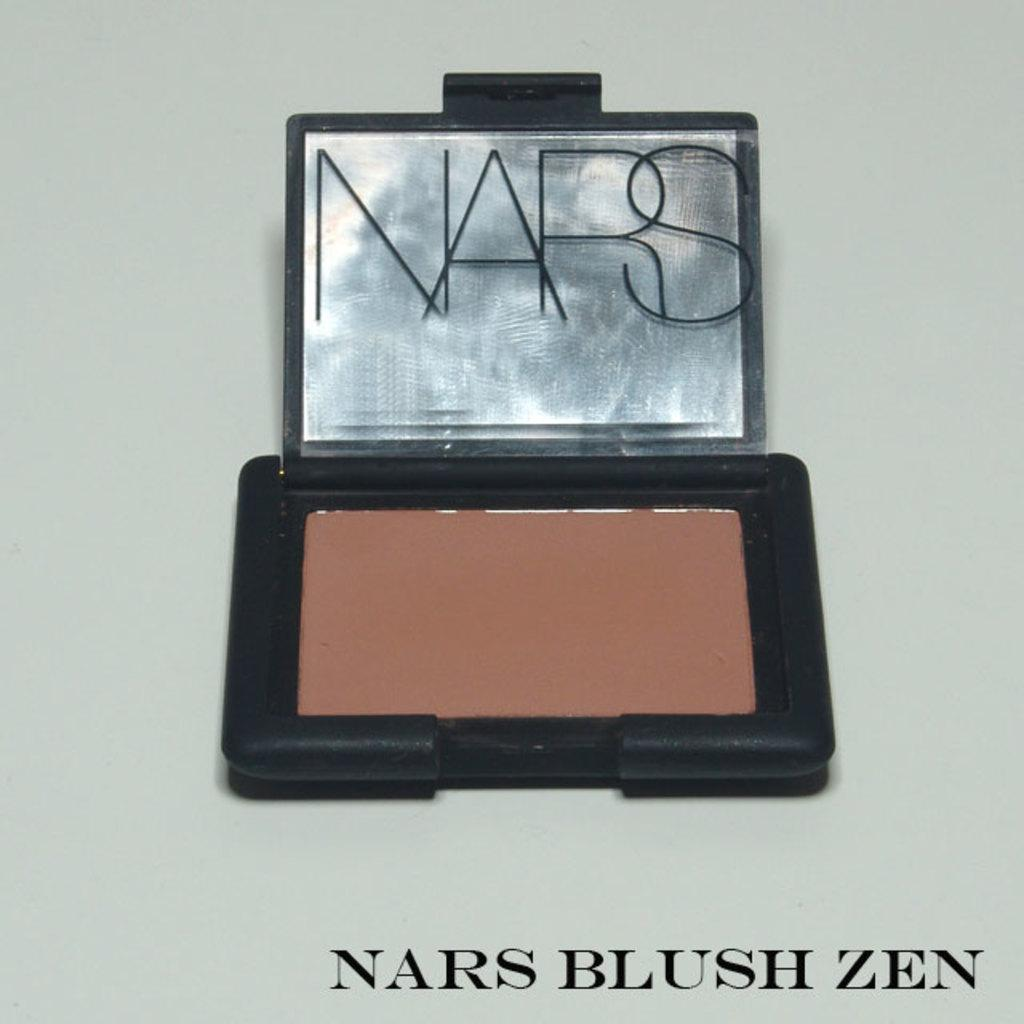<image>
Offer a succinct explanation of the picture presented. A Nars blush kit with the words Nars Blush Zen on it. 